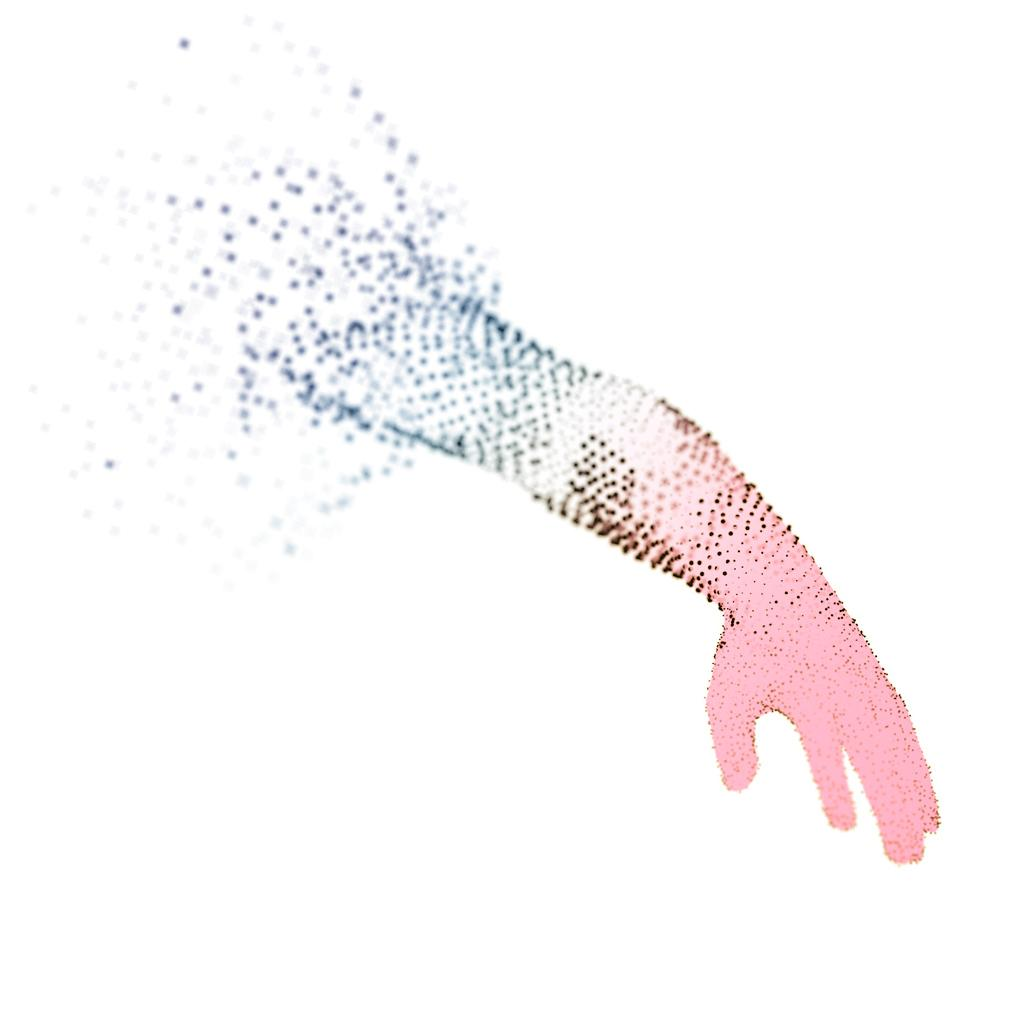What is the main subject of the image? There is an art piece in the image. What is depicted in the art piece? The art piece contains a person's hand. What is the color of the background in the art piece? The background of the art piece is white. What type of pleasure can be seen being derived from the copper edge in the image? There is no reference to pleasure, copper, or an edge in the image, so it's not possible to determine what, if any, pleasure might be derived from them. 